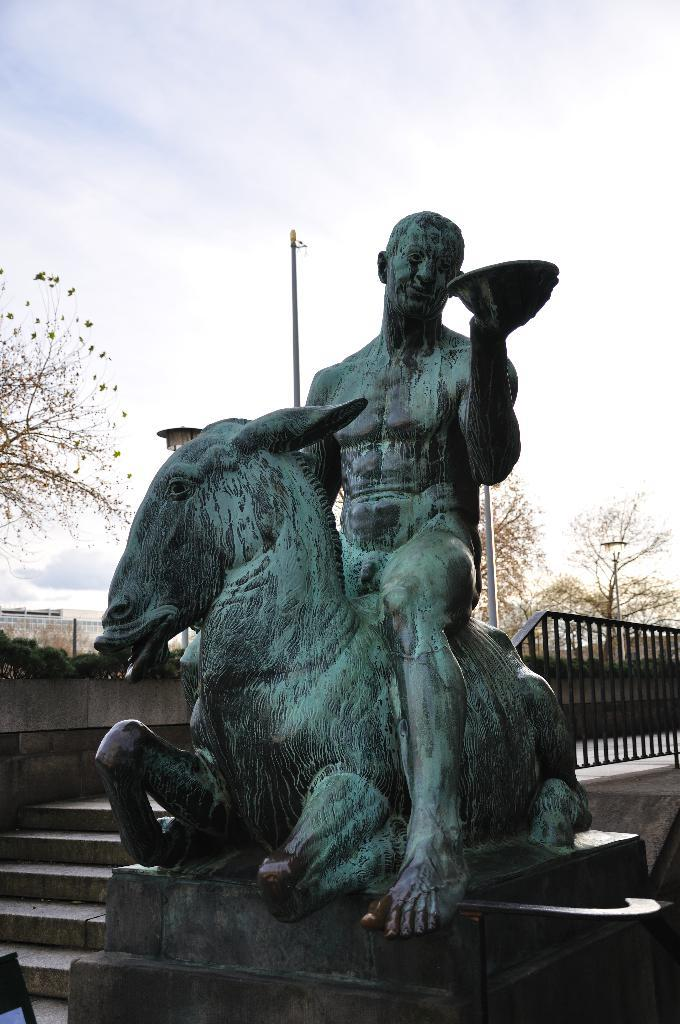What is the main object or structure in the image? There is a statue in the image. What architectural feature is present in the image? There is a staircase in the image. What safety feature is included in the image? There is railing in the image. What type of vegetation can be seen in the image? There are plants and trees in the image. What type of structure is visible in the image? There is a building in the image. What part of the natural environment is visible in the image? The sky is visible in the image. Can you tell me how many hens are sitting on the statue in the image? There are no hens present in the image; the statue is the main object in the image. What do you believe about the airplane in the image? There is no airplane present in the image, so it is not possible to form a belief about it. 